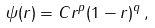<formula> <loc_0><loc_0><loc_500><loc_500>\psi ( r ) = C r ^ { p } ( 1 - r ) ^ { q } \, ,</formula> 